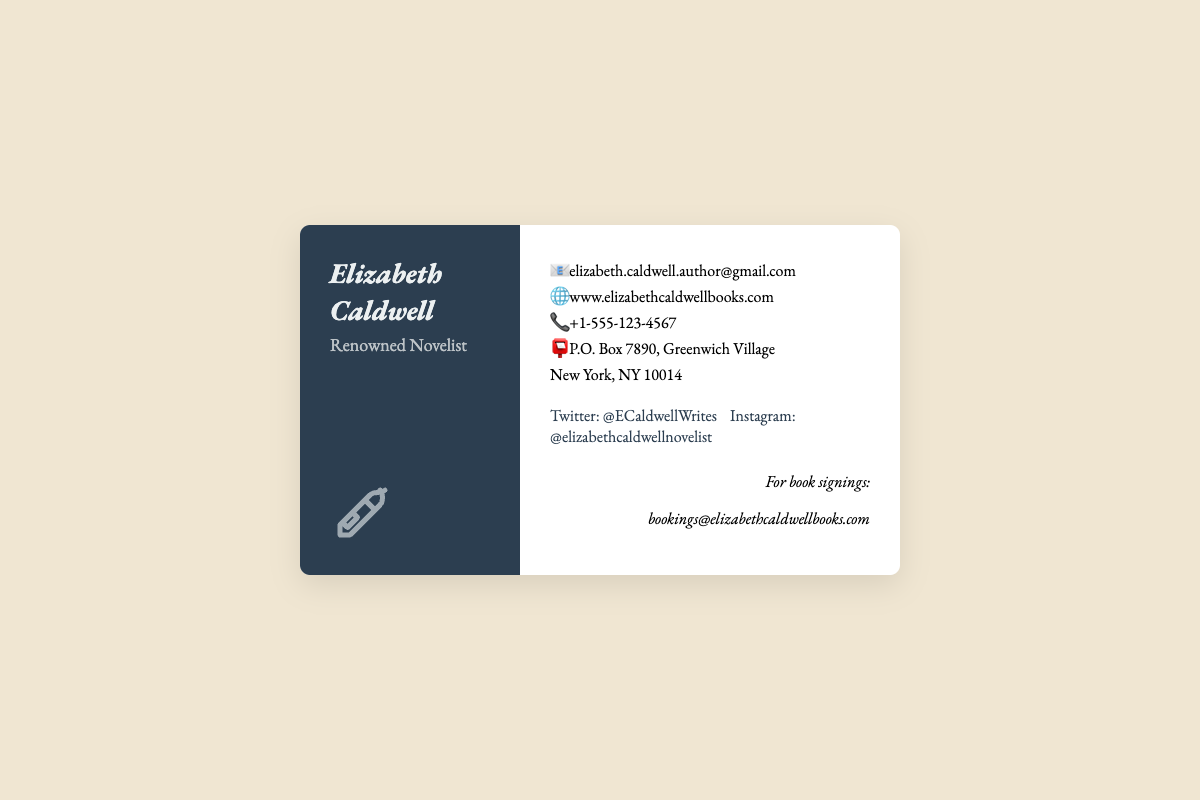What is the name of the author? The name of the author is prominently displayed at the top of the card, which is "Elizabeth Caldwell."
Answer: Elizabeth Caldwell What is the profession of Elizabeth Caldwell? Below her name, the card indicates that she is a "Renowned Novelist."
Answer: Renowned Novelist How can you contact Elizabeth Caldwell via email? The email address for contacting her is listed in the contact information section as "elizabeth.caldwell.author@gmail.com."
Answer: elizabeth.caldwell.author@gmail.com What is the phone number provided on the business card? The card lists a phone contact to reach her, which is "+1-555-123-4567."
Answer: +1-555-123-4567 Where is Elizabeth Caldwell's mailing address? The mailing address is shown in the contact information section: "P.O. Box 7890, Greenwich Village, New York, NY 10014."
Answer: P.O. Box 7890, Greenwich Village, New York, NY 10014 What is the website for Elizabeth Caldwell's books? The business card provides a website to find out more about her books: "www.elizabethcaldwellbooks.com."
Answer: www.elizabethcaldwellbooks.com What is the email address for booking book signings? In the book signings section, the email address provided for bookings is "bookings@elizabethcaldwellbooks.com."
Answer: bookings@elizabethcaldwellbooks.com Which social media platform is linked to Elizabeth Caldwell's Twitter? The card includes a link to her Twitter account "@ECaldwellWrites."
Answer: @ECaldwellWrites What type of graphic is used on the left side of the card? A quill pen logo is used, signifying the literary theme associated with the card.
Answer: Quill pen logo 